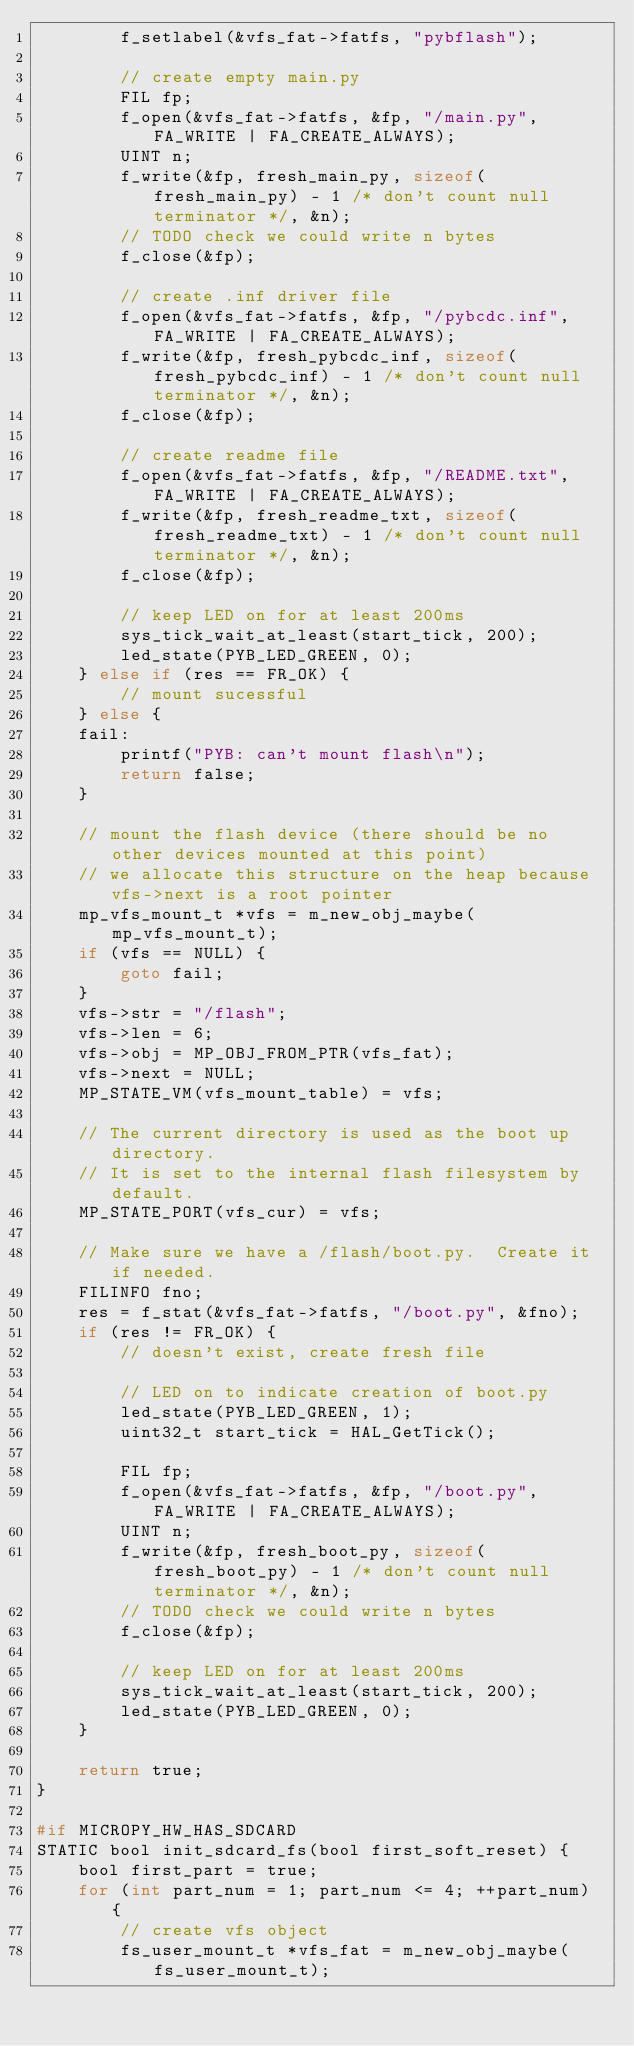<code> <loc_0><loc_0><loc_500><loc_500><_C_>        f_setlabel(&vfs_fat->fatfs, "pybflash");

        // create empty main.py
        FIL fp;
        f_open(&vfs_fat->fatfs, &fp, "/main.py", FA_WRITE | FA_CREATE_ALWAYS);
        UINT n;
        f_write(&fp, fresh_main_py, sizeof(fresh_main_py) - 1 /* don't count null terminator */, &n);
        // TODO check we could write n bytes
        f_close(&fp);

        // create .inf driver file
        f_open(&vfs_fat->fatfs, &fp, "/pybcdc.inf", FA_WRITE | FA_CREATE_ALWAYS);
        f_write(&fp, fresh_pybcdc_inf, sizeof(fresh_pybcdc_inf) - 1 /* don't count null terminator */, &n);
        f_close(&fp);

        // create readme file
        f_open(&vfs_fat->fatfs, &fp, "/README.txt", FA_WRITE | FA_CREATE_ALWAYS);
        f_write(&fp, fresh_readme_txt, sizeof(fresh_readme_txt) - 1 /* don't count null terminator */, &n);
        f_close(&fp);

        // keep LED on for at least 200ms
        sys_tick_wait_at_least(start_tick, 200);
        led_state(PYB_LED_GREEN, 0);
    } else if (res == FR_OK) {
        // mount sucessful
    } else {
    fail:
        printf("PYB: can't mount flash\n");
        return false;
    }

    // mount the flash device (there should be no other devices mounted at this point)
    // we allocate this structure on the heap because vfs->next is a root pointer
    mp_vfs_mount_t *vfs = m_new_obj_maybe(mp_vfs_mount_t);
    if (vfs == NULL) {
        goto fail;
    }
    vfs->str = "/flash";
    vfs->len = 6;
    vfs->obj = MP_OBJ_FROM_PTR(vfs_fat);
    vfs->next = NULL;
    MP_STATE_VM(vfs_mount_table) = vfs;

    // The current directory is used as the boot up directory.
    // It is set to the internal flash filesystem by default.
    MP_STATE_PORT(vfs_cur) = vfs;

    // Make sure we have a /flash/boot.py.  Create it if needed.
    FILINFO fno;
    res = f_stat(&vfs_fat->fatfs, "/boot.py", &fno);
    if (res != FR_OK) {
        // doesn't exist, create fresh file

        // LED on to indicate creation of boot.py
        led_state(PYB_LED_GREEN, 1);
        uint32_t start_tick = HAL_GetTick();

        FIL fp;
        f_open(&vfs_fat->fatfs, &fp, "/boot.py", FA_WRITE | FA_CREATE_ALWAYS);
        UINT n;
        f_write(&fp, fresh_boot_py, sizeof(fresh_boot_py) - 1 /* don't count null terminator */, &n);
        // TODO check we could write n bytes
        f_close(&fp);

        // keep LED on for at least 200ms
        sys_tick_wait_at_least(start_tick, 200);
        led_state(PYB_LED_GREEN, 0);
    }

    return true;
}

#if MICROPY_HW_HAS_SDCARD
STATIC bool init_sdcard_fs(bool first_soft_reset) {
    bool first_part = true;
    for (int part_num = 1; part_num <= 4; ++part_num) {
        // create vfs object
        fs_user_mount_t *vfs_fat = m_new_obj_maybe(fs_user_mount_t);</code> 